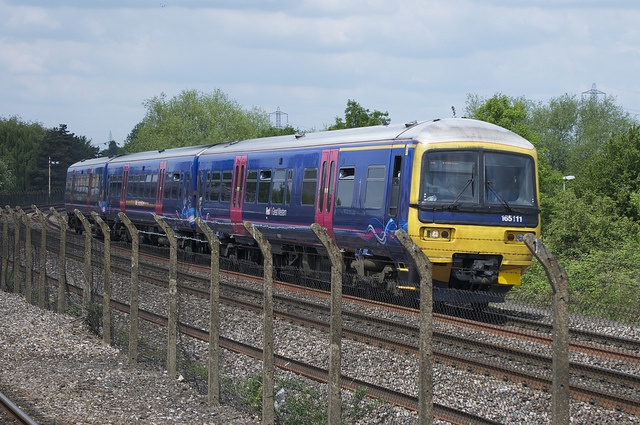Describe the objects in this image and their specific colors. I can see a train in lightblue, black, gray, and navy tones in this image. 